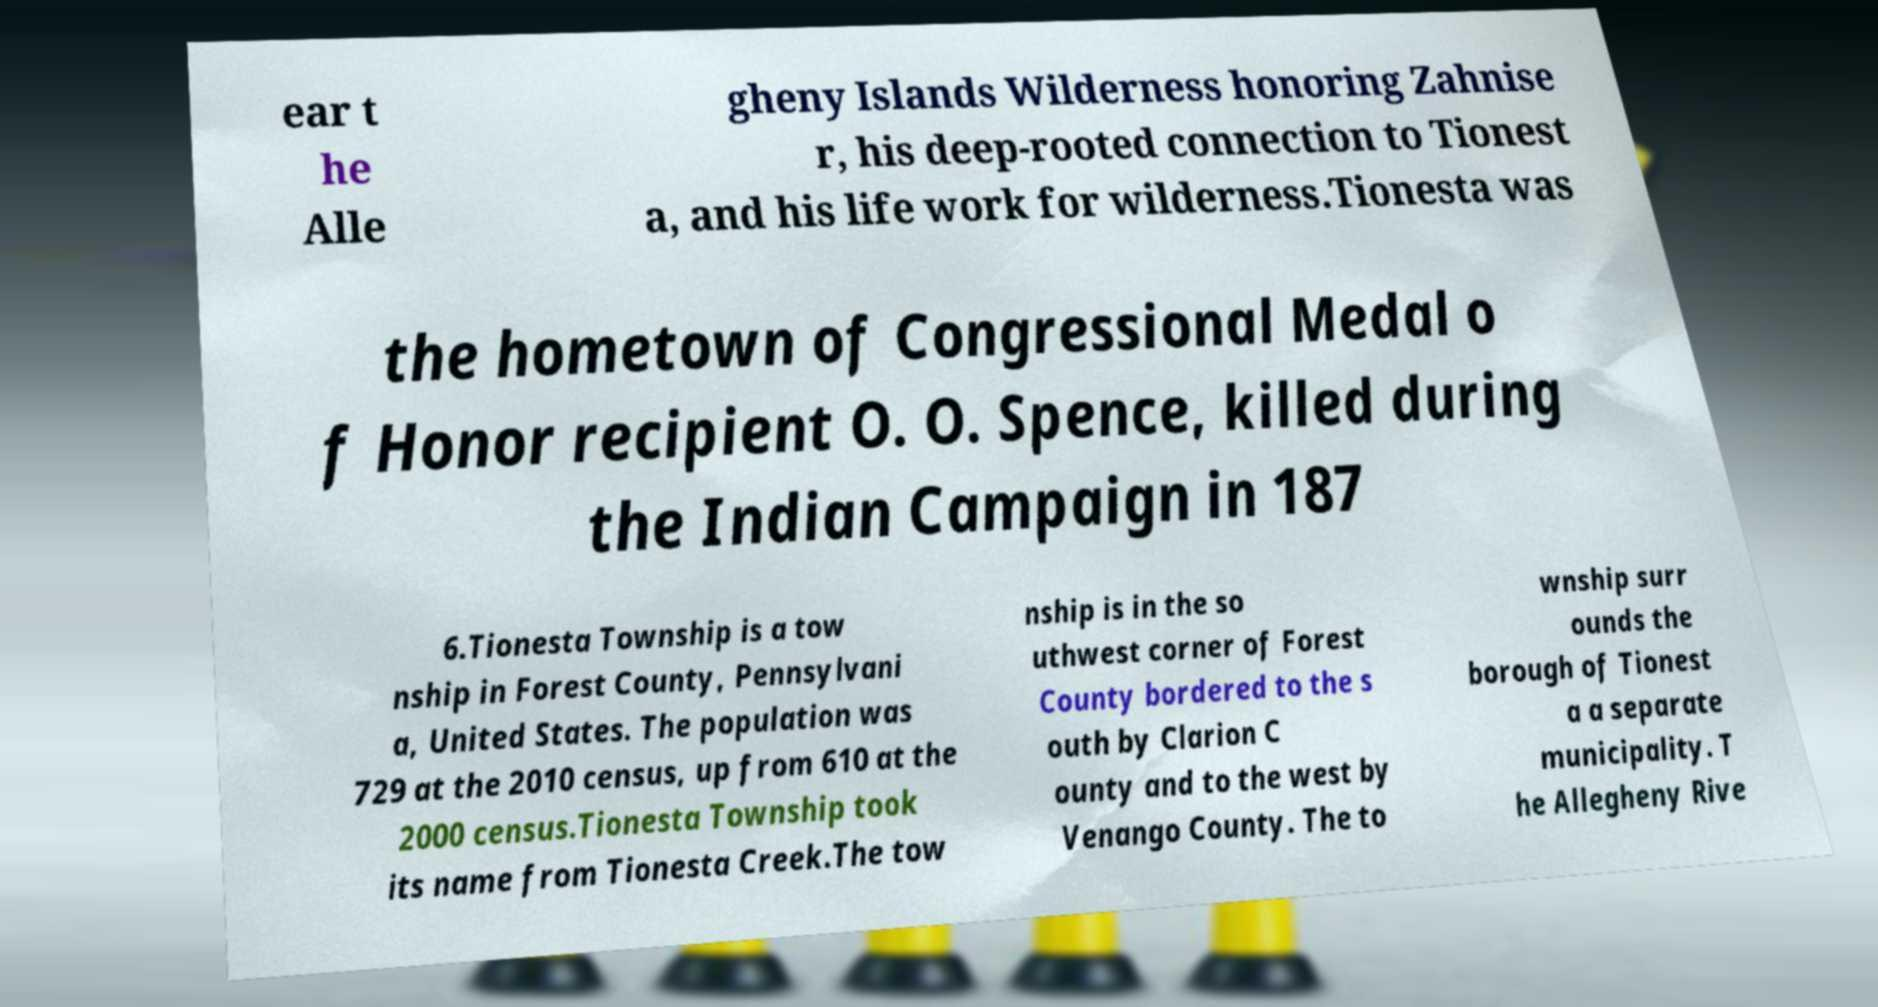Please identify and transcribe the text found in this image. ear t he Alle gheny Islands Wilderness honoring Zahnise r, his deep-rooted connection to Tionest a, and his life work for wilderness.Tionesta was the hometown of Congressional Medal o f Honor recipient O. O. Spence, killed during the Indian Campaign in 187 6.Tionesta Township is a tow nship in Forest County, Pennsylvani a, United States. The population was 729 at the 2010 census, up from 610 at the 2000 census.Tionesta Township took its name from Tionesta Creek.The tow nship is in the so uthwest corner of Forest County bordered to the s outh by Clarion C ounty and to the west by Venango County. The to wnship surr ounds the borough of Tionest a a separate municipality. T he Allegheny Rive 